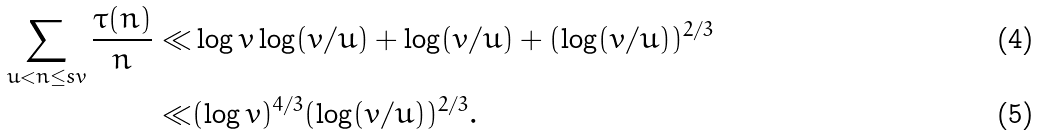Convert formula to latex. <formula><loc_0><loc_0><loc_500><loc_500>\sum _ { u < n \leq s v } \frac { \tau ( n ) } { n } \ll & \log v \log ( v / u ) + \log ( v / u ) + ( \log ( v / u ) ) ^ { 2 / 3 } \\ \ll & ( \log v ) ^ { 4 / 3 } ( \log ( v / u ) ) ^ { 2 / 3 } .</formula> 